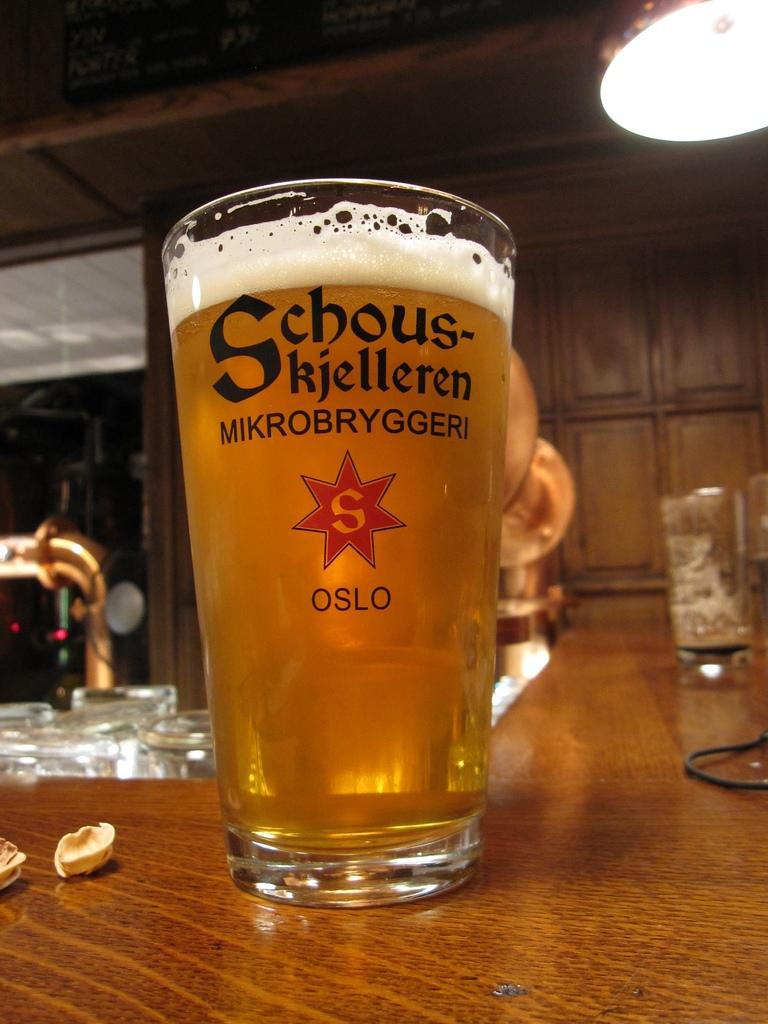<image>
Create a compact narrative representing the image presented. a glass of beer that says 'schous-kjelleren mikrobryggeri s oslo' on it 